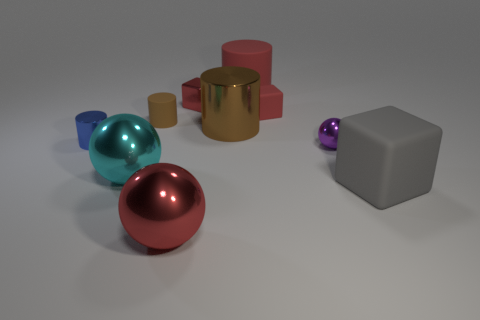What is the color of the tiny block that is in front of the tiny red metal cube? The color of the small object positioned in front of the tiny red metal cube is not visible from the current perspective. To answer accurately, a different angle that shows this detail or more information is required. 